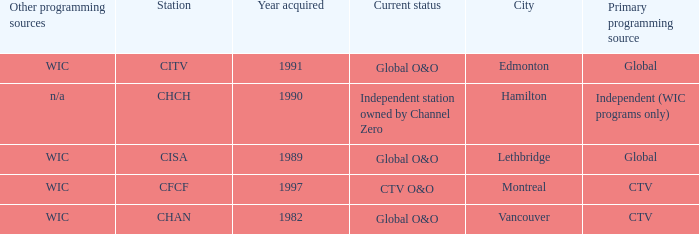How many is the minimum for citv 1991.0. 